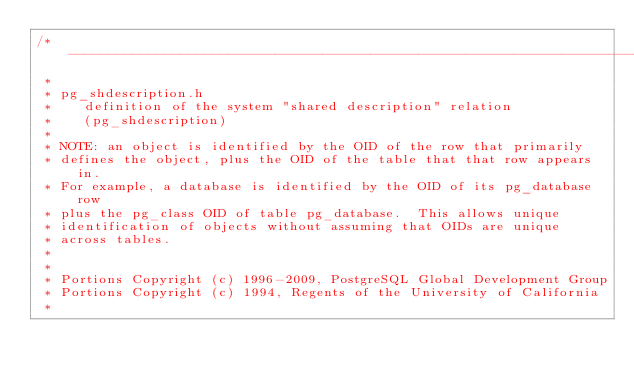Convert code to text. <code><loc_0><loc_0><loc_500><loc_500><_C_>/*-------------------------------------------------------------------------
 *
 * pg_shdescription.h
 *	  definition of the system "shared description" relation
 *	  (pg_shdescription)
 *
 * NOTE: an object is identified by the OID of the row that primarily
 * defines the object, plus the OID of the table that that row appears in.
 * For example, a database is identified by the OID of its pg_database row
 * plus the pg_class OID of table pg_database.	This allows unique
 * identification of objects without assuming that OIDs are unique
 * across tables.
 *
 *
 * Portions Copyright (c) 1996-2009, PostgreSQL Global Development Group
 * Portions Copyright (c) 1994, Regents of the University of California
 *</code> 